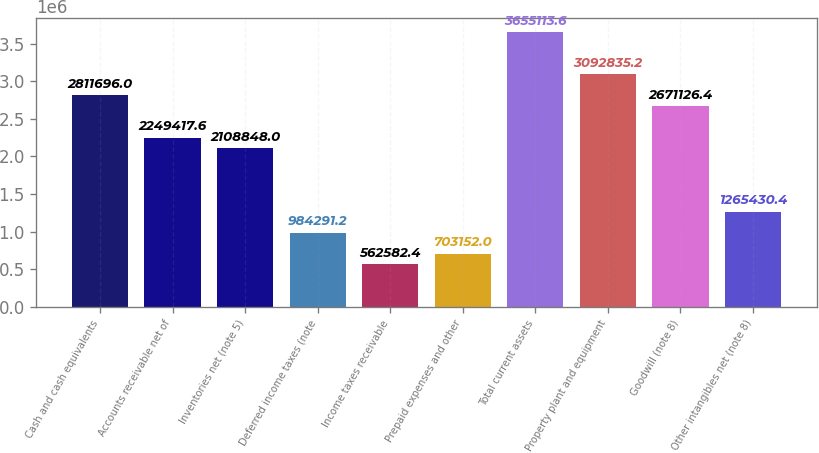<chart> <loc_0><loc_0><loc_500><loc_500><bar_chart><fcel>Cash and cash equivalents<fcel>Accounts receivable net of<fcel>Inventories net (note 5)<fcel>Deferred income taxes (note<fcel>Income taxes receivable<fcel>Prepaid expenses and other<fcel>Total current assets<fcel>Property plant and equipment<fcel>Goodwill (note 8)<fcel>Other intangibles net (note 8)<nl><fcel>2.8117e+06<fcel>2.24942e+06<fcel>2.10885e+06<fcel>984291<fcel>562582<fcel>703152<fcel>3.65511e+06<fcel>3.09284e+06<fcel>2.67113e+06<fcel>1.26543e+06<nl></chart> 